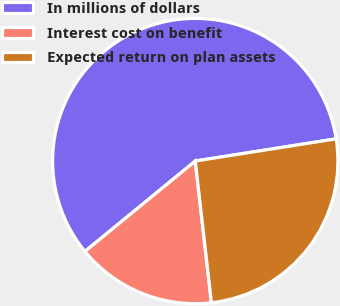<chart> <loc_0><loc_0><loc_500><loc_500><pie_chart><fcel>In millions of dollars<fcel>Interest cost on benefit<fcel>Expected return on plan assets<nl><fcel>58.43%<fcel>15.88%<fcel>25.68%<nl></chart> 